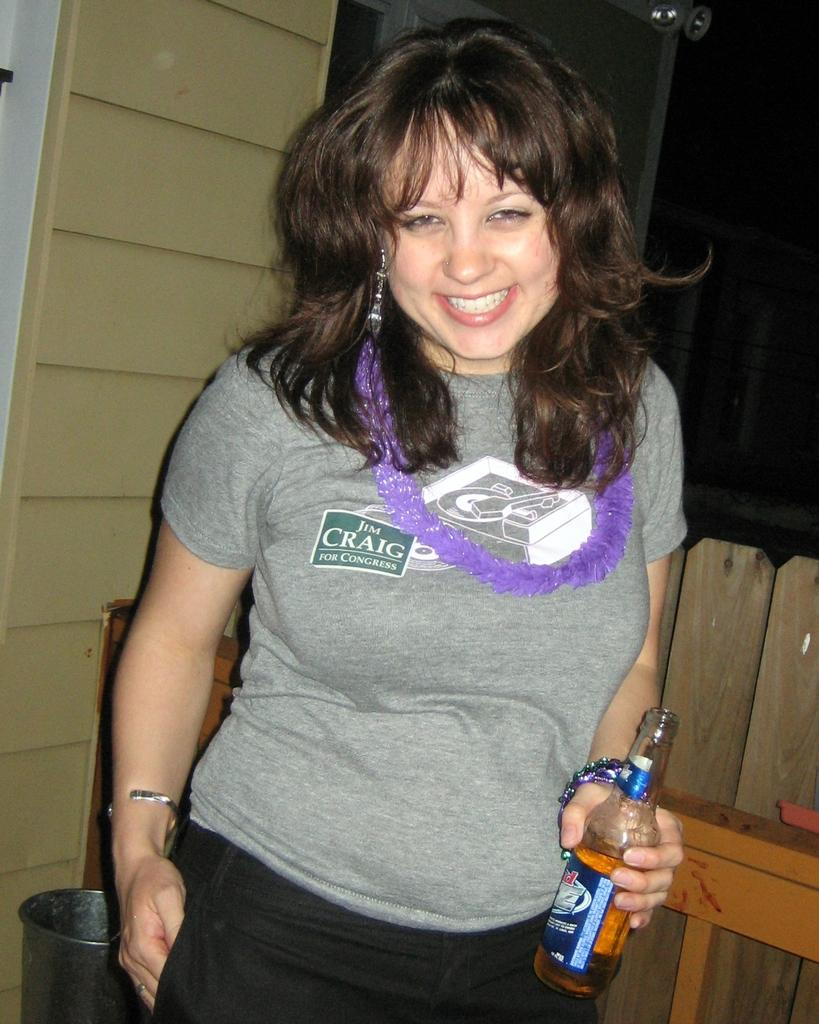<image>
Render a clear and concise summary of the photo. women drinking a beer and sponsoring Jim Craig for Congresss 